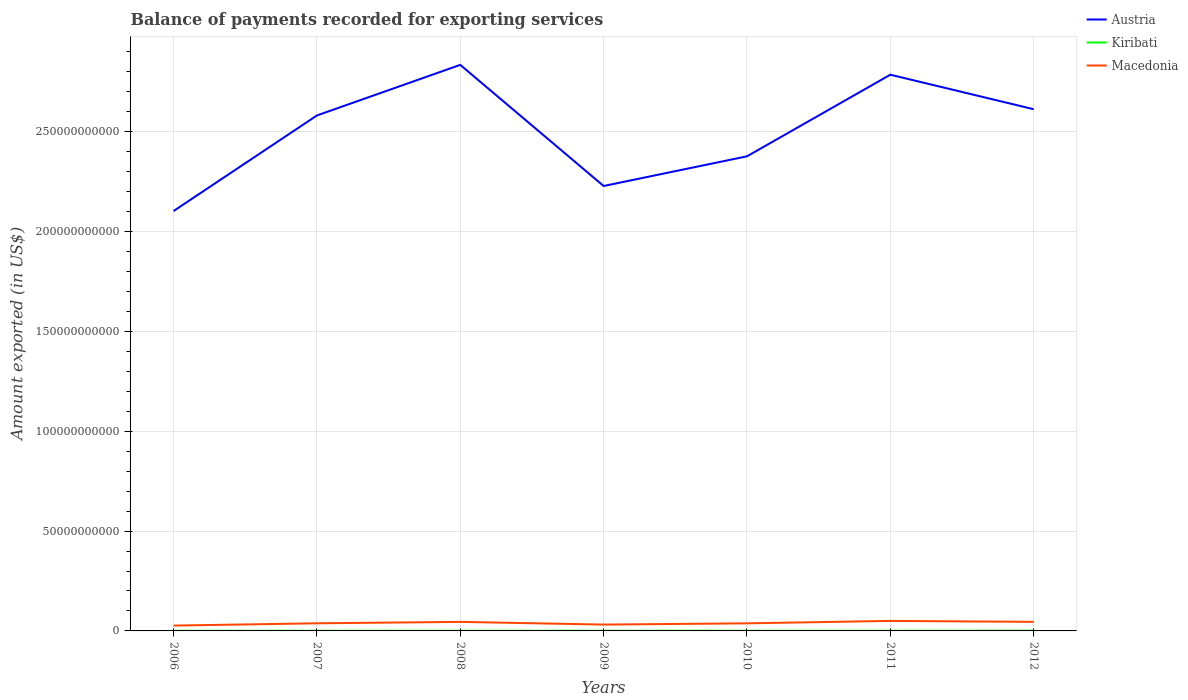How many different coloured lines are there?
Give a very brief answer. 3. Across all years, what is the maximum amount exported in Austria?
Offer a very short reply. 2.10e+11. What is the total amount exported in Austria in the graph?
Provide a short and direct response. 2.22e+1. What is the difference between the highest and the second highest amount exported in Macedonia?
Ensure brevity in your answer.  2.34e+09. How many lines are there?
Your answer should be very brief. 3. What is the difference between two consecutive major ticks on the Y-axis?
Ensure brevity in your answer.  5.00e+1. Are the values on the major ticks of Y-axis written in scientific E-notation?
Offer a very short reply. No. Does the graph contain grids?
Ensure brevity in your answer.  Yes. Where does the legend appear in the graph?
Offer a terse response. Top right. How many legend labels are there?
Keep it short and to the point. 3. How are the legend labels stacked?
Give a very brief answer. Vertical. What is the title of the graph?
Offer a terse response. Balance of payments recorded for exporting services. Does "Uganda" appear as one of the legend labels in the graph?
Your response must be concise. No. What is the label or title of the X-axis?
Provide a short and direct response. Years. What is the label or title of the Y-axis?
Make the answer very short. Amount exported (in US$). What is the Amount exported (in US$) in Austria in 2006?
Give a very brief answer. 2.10e+11. What is the Amount exported (in US$) of Kiribati in 2006?
Your answer should be very brief. 6.04e+07. What is the Amount exported (in US$) in Macedonia in 2006?
Your answer should be very brief. 2.68e+09. What is the Amount exported (in US$) of Austria in 2007?
Your answer should be very brief. 2.58e+11. What is the Amount exported (in US$) in Kiribati in 2007?
Your answer should be very brief. 8.29e+07. What is the Amount exported (in US$) in Macedonia in 2007?
Offer a very short reply. 3.82e+09. What is the Amount exported (in US$) in Austria in 2008?
Your response must be concise. 2.83e+11. What is the Amount exported (in US$) in Kiribati in 2008?
Offer a terse response. 9.38e+07. What is the Amount exported (in US$) of Macedonia in 2008?
Your answer should be very brief. 4.52e+09. What is the Amount exported (in US$) in Austria in 2009?
Your answer should be very brief. 2.23e+11. What is the Amount exported (in US$) of Kiribati in 2009?
Provide a succinct answer. 7.75e+07. What is the Amount exported (in US$) of Macedonia in 2009?
Offer a terse response. 3.18e+09. What is the Amount exported (in US$) of Austria in 2010?
Your answer should be compact. 2.38e+11. What is the Amount exported (in US$) of Kiribati in 2010?
Make the answer very short. 9.54e+07. What is the Amount exported (in US$) in Macedonia in 2010?
Ensure brevity in your answer.  3.80e+09. What is the Amount exported (in US$) of Austria in 2011?
Make the answer very short. 2.79e+11. What is the Amount exported (in US$) of Kiribati in 2011?
Offer a terse response. 9.75e+07. What is the Amount exported (in US$) in Macedonia in 2011?
Ensure brevity in your answer.  5.02e+09. What is the Amount exported (in US$) of Austria in 2012?
Give a very brief answer. 2.61e+11. What is the Amount exported (in US$) of Kiribati in 2012?
Offer a very short reply. 1.24e+08. What is the Amount exported (in US$) of Macedonia in 2012?
Your answer should be compact. 4.53e+09. Across all years, what is the maximum Amount exported (in US$) of Austria?
Ensure brevity in your answer.  2.83e+11. Across all years, what is the maximum Amount exported (in US$) of Kiribati?
Provide a succinct answer. 1.24e+08. Across all years, what is the maximum Amount exported (in US$) of Macedonia?
Provide a short and direct response. 5.02e+09. Across all years, what is the minimum Amount exported (in US$) of Austria?
Ensure brevity in your answer.  2.10e+11. Across all years, what is the minimum Amount exported (in US$) of Kiribati?
Give a very brief answer. 6.04e+07. Across all years, what is the minimum Amount exported (in US$) in Macedonia?
Offer a terse response. 2.68e+09. What is the total Amount exported (in US$) in Austria in the graph?
Keep it short and to the point. 1.75e+12. What is the total Amount exported (in US$) in Kiribati in the graph?
Offer a terse response. 6.32e+08. What is the total Amount exported (in US$) in Macedonia in the graph?
Your response must be concise. 2.76e+1. What is the difference between the Amount exported (in US$) in Austria in 2006 and that in 2007?
Your response must be concise. -4.79e+1. What is the difference between the Amount exported (in US$) of Kiribati in 2006 and that in 2007?
Your answer should be compact. -2.25e+07. What is the difference between the Amount exported (in US$) of Macedonia in 2006 and that in 2007?
Provide a succinct answer. -1.14e+09. What is the difference between the Amount exported (in US$) in Austria in 2006 and that in 2008?
Keep it short and to the point. -7.32e+1. What is the difference between the Amount exported (in US$) in Kiribati in 2006 and that in 2008?
Offer a terse response. -3.34e+07. What is the difference between the Amount exported (in US$) of Macedonia in 2006 and that in 2008?
Give a very brief answer. -1.85e+09. What is the difference between the Amount exported (in US$) of Austria in 2006 and that in 2009?
Ensure brevity in your answer.  -1.25e+1. What is the difference between the Amount exported (in US$) in Kiribati in 2006 and that in 2009?
Offer a very short reply. -1.72e+07. What is the difference between the Amount exported (in US$) of Macedonia in 2006 and that in 2009?
Make the answer very short. -4.97e+08. What is the difference between the Amount exported (in US$) of Austria in 2006 and that in 2010?
Your response must be concise. -2.74e+1. What is the difference between the Amount exported (in US$) of Kiribati in 2006 and that in 2010?
Provide a succinct answer. -3.50e+07. What is the difference between the Amount exported (in US$) in Macedonia in 2006 and that in 2010?
Make the answer very short. -1.12e+09. What is the difference between the Amount exported (in US$) in Austria in 2006 and that in 2011?
Your answer should be compact. -6.83e+1. What is the difference between the Amount exported (in US$) of Kiribati in 2006 and that in 2011?
Your response must be concise. -3.71e+07. What is the difference between the Amount exported (in US$) in Macedonia in 2006 and that in 2011?
Ensure brevity in your answer.  -2.34e+09. What is the difference between the Amount exported (in US$) of Austria in 2006 and that in 2012?
Provide a succinct answer. -5.10e+1. What is the difference between the Amount exported (in US$) of Kiribati in 2006 and that in 2012?
Provide a succinct answer. -6.40e+07. What is the difference between the Amount exported (in US$) in Macedonia in 2006 and that in 2012?
Ensure brevity in your answer.  -1.86e+09. What is the difference between the Amount exported (in US$) of Austria in 2007 and that in 2008?
Ensure brevity in your answer.  -2.53e+1. What is the difference between the Amount exported (in US$) in Kiribati in 2007 and that in 2008?
Offer a very short reply. -1.09e+07. What is the difference between the Amount exported (in US$) in Macedonia in 2007 and that in 2008?
Your answer should be very brief. -7.03e+08. What is the difference between the Amount exported (in US$) in Austria in 2007 and that in 2009?
Your answer should be very brief. 3.53e+1. What is the difference between the Amount exported (in US$) of Kiribati in 2007 and that in 2009?
Your answer should be very brief. 5.38e+06. What is the difference between the Amount exported (in US$) in Macedonia in 2007 and that in 2009?
Keep it short and to the point. 6.46e+08. What is the difference between the Amount exported (in US$) of Austria in 2007 and that in 2010?
Keep it short and to the point. 2.05e+1. What is the difference between the Amount exported (in US$) in Kiribati in 2007 and that in 2010?
Your response must be concise. -1.25e+07. What is the difference between the Amount exported (in US$) of Macedonia in 2007 and that in 2010?
Your answer should be compact. 2.02e+07. What is the difference between the Amount exported (in US$) in Austria in 2007 and that in 2011?
Offer a very short reply. -2.04e+1. What is the difference between the Amount exported (in US$) in Kiribati in 2007 and that in 2011?
Ensure brevity in your answer.  -1.46e+07. What is the difference between the Amount exported (in US$) in Macedonia in 2007 and that in 2011?
Your response must be concise. -1.20e+09. What is the difference between the Amount exported (in US$) of Austria in 2007 and that in 2012?
Keep it short and to the point. -3.13e+09. What is the difference between the Amount exported (in US$) of Kiribati in 2007 and that in 2012?
Your answer should be very brief. -4.15e+07. What is the difference between the Amount exported (in US$) in Macedonia in 2007 and that in 2012?
Your response must be concise. -7.14e+08. What is the difference between the Amount exported (in US$) in Austria in 2008 and that in 2009?
Your answer should be very brief. 6.07e+1. What is the difference between the Amount exported (in US$) in Kiribati in 2008 and that in 2009?
Your answer should be very brief. 1.63e+07. What is the difference between the Amount exported (in US$) in Macedonia in 2008 and that in 2009?
Offer a terse response. 1.35e+09. What is the difference between the Amount exported (in US$) in Austria in 2008 and that in 2010?
Give a very brief answer. 4.58e+1. What is the difference between the Amount exported (in US$) in Kiribati in 2008 and that in 2010?
Keep it short and to the point. -1.56e+06. What is the difference between the Amount exported (in US$) in Macedonia in 2008 and that in 2010?
Your answer should be compact. 7.23e+08. What is the difference between the Amount exported (in US$) in Austria in 2008 and that in 2011?
Give a very brief answer. 4.93e+09. What is the difference between the Amount exported (in US$) of Kiribati in 2008 and that in 2011?
Your answer should be very brief. -3.68e+06. What is the difference between the Amount exported (in US$) of Macedonia in 2008 and that in 2011?
Give a very brief answer. -4.95e+08. What is the difference between the Amount exported (in US$) of Austria in 2008 and that in 2012?
Your response must be concise. 2.22e+1. What is the difference between the Amount exported (in US$) in Kiribati in 2008 and that in 2012?
Make the answer very short. -3.05e+07. What is the difference between the Amount exported (in US$) in Macedonia in 2008 and that in 2012?
Offer a terse response. -1.05e+07. What is the difference between the Amount exported (in US$) of Austria in 2009 and that in 2010?
Provide a short and direct response. -1.49e+1. What is the difference between the Amount exported (in US$) in Kiribati in 2009 and that in 2010?
Your answer should be compact. -1.79e+07. What is the difference between the Amount exported (in US$) in Macedonia in 2009 and that in 2010?
Provide a succinct answer. -6.26e+08. What is the difference between the Amount exported (in US$) of Austria in 2009 and that in 2011?
Offer a terse response. -5.57e+1. What is the difference between the Amount exported (in US$) of Kiribati in 2009 and that in 2011?
Your response must be concise. -2.00e+07. What is the difference between the Amount exported (in US$) of Macedonia in 2009 and that in 2011?
Make the answer very short. -1.84e+09. What is the difference between the Amount exported (in US$) in Austria in 2009 and that in 2012?
Ensure brevity in your answer.  -3.85e+1. What is the difference between the Amount exported (in US$) of Kiribati in 2009 and that in 2012?
Give a very brief answer. -4.68e+07. What is the difference between the Amount exported (in US$) in Macedonia in 2009 and that in 2012?
Give a very brief answer. -1.36e+09. What is the difference between the Amount exported (in US$) of Austria in 2010 and that in 2011?
Keep it short and to the point. -4.09e+1. What is the difference between the Amount exported (in US$) of Kiribati in 2010 and that in 2011?
Provide a succinct answer. -2.12e+06. What is the difference between the Amount exported (in US$) in Macedonia in 2010 and that in 2011?
Offer a terse response. -1.22e+09. What is the difference between the Amount exported (in US$) in Austria in 2010 and that in 2012?
Ensure brevity in your answer.  -2.36e+1. What is the difference between the Amount exported (in US$) in Kiribati in 2010 and that in 2012?
Ensure brevity in your answer.  -2.90e+07. What is the difference between the Amount exported (in US$) of Macedonia in 2010 and that in 2012?
Offer a terse response. -7.34e+08. What is the difference between the Amount exported (in US$) in Austria in 2011 and that in 2012?
Your answer should be compact. 1.73e+1. What is the difference between the Amount exported (in US$) of Kiribati in 2011 and that in 2012?
Your answer should be compact. -2.69e+07. What is the difference between the Amount exported (in US$) in Macedonia in 2011 and that in 2012?
Offer a very short reply. 4.85e+08. What is the difference between the Amount exported (in US$) of Austria in 2006 and the Amount exported (in US$) of Kiribati in 2007?
Offer a very short reply. 2.10e+11. What is the difference between the Amount exported (in US$) of Austria in 2006 and the Amount exported (in US$) of Macedonia in 2007?
Offer a very short reply. 2.06e+11. What is the difference between the Amount exported (in US$) of Kiribati in 2006 and the Amount exported (in US$) of Macedonia in 2007?
Provide a short and direct response. -3.76e+09. What is the difference between the Amount exported (in US$) of Austria in 2006 and the Amount exported (in US$) of Kiribati in 2008?
Your answer should be compact. 2.10e+11. What is the difference between the Amount exported (in US$) of Austria in 2006 and the Amount exported (in US$) of Macedonia in 2008?
Your answer should be very brief. 2.06e+11. What is the difference between the Amount exported (in US$) of Kiribati in 2006 and the Amount exported (in US$) of Macedonia in 2008?
Make the answer very short. -4.46e+09. What is the difference between the Amount exported (in US$) in Austria in 2006 and the Amount exported (in US$) in Kiribati in 2009?
Make the answer very short. 2.10e+11. What is the difference between the Amount exported (in US$) of Austria in 2006 and the Amount exported (in US$) of Macedonia in 2009?
Make the answer very short. 2.07e+11. What is the difference between the Amount exported (in US$) of Kiribati in 2006 and the Amount exported (in US$) of Macedonia in 2009?
Your response must be concise. -3.11e+09. What is the difference between the Amount exported (in US$) of Austria in 2006 and the Amount exported (in US$) of Kiribati in 2010?
Provide a short and direct response. 2.10e+11. What is the difference between the Amount exported (in US$) of Austria in 2006 and the Amount exported (in US$) of Macedonia in 2010?
Your answer should be very brief. 2.06e+11. What is the difference between the Amount exported (in US$) of Kiribati in 2006 and the Amount exported (in US$) of Macedonia in 2010?
Offer a very short reply. -3.74e+09. What is the difference between the Amount exported (in US$) of Austria in 2006 and the Amount exported (in US$) of Kiribati in 2011?
Your answer should be very brief. 2.10e+11. What is the difference between the Amount exported (in US$) of Austria in 2006 and the Amount exported (in US$) of Macedonia in 2011?
Ensure brevity in your answer.  2.05e+11. What is the difference between the Amount exported (in US$) of Kiribati in 2006 and the Amount exported (in US$) of Macedonia in 2011?
Your answer should be very brief. -4.96e+09. What is the difference between the Amount exported (in US$) in Austria in 2006 and the Amount exported (in US$) in Kiribati in 2012?
Give a very brief answer. 2.10e+11. What is the difference between the Amount exported (in US$) in Austria in 2006 and the Amount exported (in US$) in Macedonia in 2012?
Provide a succinct answer. 2.06e+11. What is the difference between the Amount exported (in US$) in Kiribati in 2006 and the Amount exported (in US$) in Macedonia in 2012?
Your answer should be compact. -4.47e+09. What is the difference between the Amount exported (in US$) of Austria in 2007 and the Amount exported (in US$) of Kiribati in 2008?
Your answer should be compact. 2.58e+11. What is the difference between the Amount exported (in US$) of Austria in 2007 and the Amount exported (in US$) of Macedonia in 2008?
Keep it short and to the point. 2.54e+11. What is the difference between the Amount exported (in US$) in Kiribati in 2007 and the Amount exported (in US$) in Macedonia in 2008?
Provide a short and direct response. -4.44e+09. What is the difference between the Amount exported (in US$) of Austria in 2007 and the Amount exported (in US$) of Kiribati in 2009?
Your answer should be compact. 2.58e+11. What is the difference between the Amount exported (in US$) in Austria in 2007 and the Amount exported (in US$) in Macedonia in 2009?
Provide a short and direct response. 2.55e+11. What is the difference between the Amount exported (in US$) of Kiribati in 2007 and the Amount exported (in US$) of Macedonia in 2009?
Your answer should be compact. -3.09e+09. What is the difference between the Amount exported (in US$) of Austria in 2007 and the Amount exported (in US$) of Kiribati in 2010?
Make the answer very short. 2.58e+11. What is the difference between the Amount exported (in US$) of Austria in 2007 and the Amount exported (in US$) of Macedonia in 2010?
Offer a terse response. 2.54e+11. What is the difference between the Amount exported (in US$) of Kiribati in 2007 and the Amount exported (in US$) of Macedonia in 2010?
Keep it short and to the point. -3.72e+09. What is the difference between the Amount exported (in US$) of Austria in 2007 and the Amount exported (in US$) of Kiribati in 2011?
Offer a terse response. 2.58e+11. What is the difference between the Amount exported (in US$) in Austria in 2007 and the Amount exported (in US$) in Macedonia in 2011?
Ensure brevity in your answer.  2.53e+11. What is the difference between the Amount exported (in US$) in Kiribati in 2007 and the Amount exported (in US$) in Macedonia in 2011?
Give a very brief answer. -4.94e+09. What is the difference between the Amount exported (in US$) in Austria in 2007 and the Amount exported (in US$) in Kiribati in 2012?
Your response must be concise. 2.58e+11. What is the difference between the Amount exported (in US$) in Austria in 2007 and the Amount exported (in US$) in Macedonia in 2012?
Give a very brief answer. 2.54e+11. What is the difference between the Amount exported (in US$) in Kiribati in 2007 and the Amount exported (in US$) in Macedonia in 2012?
Your answer should be very brief. -4.45e+09. What is the difference between the Amount exported (in US$) in Austria in 2008 and the Amount exported (in US$) in Kiribati in 2009?
Make the answer very short. 2.83e+11. What is the difference between the Amount exported (in US$) of Austria in 2008 and the Amount exported (in US$) of Macedonia in 2009?
Provide a succinct answer. 2.80e+11. What is the difference between the Amount exported (in US$) of Kiribati in 2008 and the Amount exported (in US$) of Macedonia in 2009?
Ensure brevity in your answer.  -3.08e+09. What is the difference between the Amount exported (in US$) of Austria in 2008 and the Amount exported (in US$) of Kiribati in 2010?
Make the answer very short. 2.83e+11. What is the difference between the Amount exported (in US$) in Austria in 2008 and the Amount exported (in US$) in Macedonia in 2010?
Provide a short and direct response. 2.80e+11. What is the difference between the Amount exported (in US$) in Kiribati in 2008 and the Amount exported (in US$) in Macedonia in 2010?
Provide a succinct answer. -3.71e+09. What is the difference between the Amount exported (in US$) in Austria in 2008 and the Amount exported (in US$) in Kiribati in 2011?
Offer a terse response. 2.83e+11. What is the difference between the Amount exported (in US$) in Austria in 2008 and the Amount exported (in US$) in Macedonia in 2011?
Give a very brief answer. 2.78e+11. What is the difference between the Amount exported (in US$) in Kiribati in 2008 and the Amount exported (in US$) in Macedonia in 2011?
Offer a very short reply. -4.93e+09. What is the difference between the Amount exported (in US$) in Austria in 2008 and the Amount exported (in US$) in Kiribati in 2012?
Offer a very short reply. 2.83e+11. What is the difference between the Amount exported (in US$) in Austria in 2008 and the Amount exported (in US$) in Macedonia in 2012?
Offer a terse response. 2.79e+11. What is the difference between the Amount exported (in US$) in Kiribati in 2008 and the Amount exported (in US$) in Macedonia in 2012?
Your answer should be very brief. -4.44e+09. What is the difference between the Amount exported (in US$) in Austria in 2009 and the Amount exported (in US$) in Kiribati in 2010?
Your answer should be compact. 2.23e+11. What is the difference between the Amount exported (in US$) in Austria in 2009 and the Amount exported (in US$) in Macedonia in 2010?
Your answer should be very brief. 2.19e+11. What is the difference between the Amount exported (in US$) in Kiribati in 2009 and the Amount exported (in US$) in Macedonia in 2010?
Make the answer very short. -3.72e+09. What is the difference between the Amount exported (in US$) of Austria in 2009 and the Amount exported (in US$) of Kiribati in 2011?
Give a very brief answer. 2.23e+11. What is the difference between the Amount exported (in US$) in Austria in 2009 and the Amount exported (in US$) in Macedonia in 2011?
Your response must be concise. 2.18e+11. What is the difference between the Amount exported (in US$) in Kiribati in 2009 and the Amount exported (in US$) in Macedonia in 2011?
Offer a terse response. -4.94e+09. What is the difference between the Amount exported (in US$) of Austria in 2009 and the Amount exported (in US$) of Kiribati in 2012?
Ensure brevity in your answer.  2.23e+11. What is the difference between the Amount exported (in US$) of Austria in 2009 and the Amount exported (in US$) of Macedonia in 2012?
Your answer should be compact. 2.18e+11. What is the difference between the Amount exported (in US$) in Kiribati in 2009 and the Amount exported (in US$) in Macedonia in 2012?
Offer a very short reply. -4.46e+09. What is the difference between the Amount exported (in US$) of Austria in 2010 and the Amount exported (in US$) of Kiribati in 2011?
Offer a terse response. 2.38e+11. What is the difference between the Amount exported (in US$) in Austria in 2010 and the Amount exported (in US$) in Macedonia in 2011?
Provide a succinct answer. 2.33e+11. What is the difference between the Amount exported (in US$) of Kiribati in 2010 and the Amount exported (in US$) of Macedonia in 2011?
Your answer should be very brief. -4.92e+09. What is the difference between the Amount exported (in US$) in Austria in 2010 and the Amount exported (in US$) in Kiribati in 2012?
Provide a succinct answer. 2.38e+11. What is the difference between the Amount exported (in US$) of Austria in 2010 and the Amount exported (in US$) of Macedonia in 2012?
Keep it short and to the point. 2.33e+11. What is the difference between the Amount exported (in US$) of Kiribati in 2010 and the Amount exported (in US$) of Macedonia in 2012?
Offer a very short reply. -4.44e+09. What is the difference between the Amount exported (in US$) in Austria in 2011 and the Amount exported (in US$) in Kiribati in 2012?
Offer a very short reply. 2.78e+11. What is the difference between the Amount exported (in US$) in Austria in 2011 and the Amount exported (in US$) in Macedonia in 2012?
Your response must be concise. 2.74e+11. What is the difference between the Amount exported (in US$) in Kiribati in 2011 and the Amount exported (in US$) in Macedonia in 2012?
Keep it short and to the point. -4.44e+09. What is the average Amount exported (in US$) of Austria per year?
Give a very brief answer. 2.50e+11. What is the average Amount exported (in US$) of Kiribati per year?
Make the answer very short. 9.03e+07. What is the average Amount exported (in US$) in Macedonia per year?
Keep it short and to the point. 3.94e+09. In the year 2006, what is the difference between the Amount exported (in US$) of Austria and Amount exported (in US$) of Kiribati?
Your response must be concise. 2.10e+11. In the year 2006, what is the difference between the Amount exported (in US$) in Austria and Amount exported (in US$) in Macedonia?
Give a very brief answer. 2.08e+11. In the year 2006, what is the difference between the Amount exported (in US$) of Kiribati and Amount exported (in US$) of Macedonia?
Offer a very short reply. -2.62e+09. In the year 2007, what is the difference between the Amount exported (in US$) of Austria and Amount exported (in US$) of Kiribati?
Your answer should be very brief. 2.58e+11. In the year 2007, what is the difference between the Amount exported (in US$) of Austria and Amount exported (in US$) of Macedonia?
Your answer should be very brief. 2.54e+11. In the year 2007, what is the difference between the Amount exported (in US$) of Kiribati and Amount exported (in US$) of Macedonia?
Keep it short and to the point. -3.74e+09. In the year 2008, what is the difference between the Amount exported (in US$) in Austria and Amount exported (in US$) in Kiribati?
Your answer should be very brief. 2.83e+11. In the year 2008, what is the difference between the Amount exported (in US$) in Austria and Amount exported (in US$) in Macedonia?
Your response must be concise. 2.79e+11. In the year 2008, what is the difference between the Amount exported (in US$) in Kiribati and Amount exported (in US$) in Macedonia?
Provide a short and direct response. -4.43e+09. In the year 2009, what is the difference between the Amount exported (in US$) in Austria and Amount exported (in US$) in Kiribati?
Provide a short and direct response. 2.23e+11. In the year 2009, what is the difference between the Amount exported (in US$) of Austria and Amount exported (in US$) of Macedonia?
Make the answer very short. 2.20e+11. In the year 2009, what is the difference between the Amount exported (in US$) of Kiribati and Amount exported (in US$) of Macedonia?
Your answer should be compact. -3.10e+09. In the year 2010, what is the difference between the Amount exported (in US$) of Austria and Amount exported (in US$) of Kiribati?
Your answer should be very brief. 2.38e+11. In the year 2010, what is the difference between the Amount exported (in US$) in Austria and Amount exported (in US$) in Macedonia?
Offer a very short reply. 2.34e+11. In the year 2010, what is the difference between the Amount exported (in US$) of Kiribati and Amount exported (in US$) of Macedonia?
Offer a terse response. -3.71e+09. In the year 2011, what is the difference between the Amount exported (in US$) in Austria and Amount exported (in US$) in Kiribati?
Ensure brevity in your answer.  2.78e+11. In the year 2011, what is the difference between the Amount exported (in US$) in Austria and Amount exported (in US$) in Macedonia?
Offer a terse response. 2.74e+11. In the year 2011, what is the difference between the Amount exported (in US$) in Kiribati and Amount exported (in US$) in Macedonia?
Provide a succinct answer. -4.92e+09. In the year 2012, what is the difference between the Amount exported (in US$) in Austria and Amount exported (in US$) in Kiribati?
Provide a short and direct response. 2.61e+11. In the year 2012, what is the difference between the Amount exported (in US$) in Austria and Amount exported (in US$) in Macedonia?
Your answer should be very brief. 2.57e+11. In the year 2012, what is the difference between the Amount exported (in US$) in Kiribati and Amount exported (in US$) in Macedonia?
Your answer should be very brief. -4.41e+09. What is the ratio of the Amount exported (in US$) of Austria in 2006 to that in 2007?
Offer a terse response. 0.81. What is the ratio of the Amount exported (in US$) of Kiribati in 2006 to that in 2007?
Keep it short and to the point. 0.73. What is the ratio of the Amount exported (in US$) of Macedonia in 2006 to that in 2007?
Keep it short and to the point. 0.7. What is the ratio of the Amount exported (in US$) of Austria in 2006 to that in 2008?
Ensure brevity in your answer.  0.74. What is the ratio of the Amount exported (in US$) of Kiribati in 2006 to that in 2008?
Keep it short and to the point. 0.64. What is the ratio of the Amount exported (in US$) of Macedonia in 2006 to that in 2008?
Give a very brief answer. 0.59. What is the ratio of the Amount exported (in US$) of Austria in 2006 to that in 2009?
Make the answer very short. 0.94. What is the ratio of the Amount exported (in US$) in Kiribati in 2006 to that in 2009?
Keep it short and to the point. 0.78. What is the ratio of the Amount exported (in US$) in Macedonia in 2006 to that in 2009?
Make the answer very short. 0.84. What is the ratio of the Amount exported (in US$) in Austria in 2006 to that in 2010?
Give a very brief answer. 0.88. What is the ratio of the Amount exported (in US$) in Kiribati in 2006 to that in 2010?
Your answer should be very brief. 0.63. What is the ratio of the Amount exported (in US$) of Macedonia in 2006 to that in 2010?
Keep it short and to the point. 0.7. What is the ratio of the Amount exported (in US$) of Austria in 2006 to that in 2011?
Keep it short and to the point. 0.75. What is the ratio of the Amount exported (in US$) in Kiribati in 2006 to that in 2011?
Ensure brevity in your answer.  0.62. What is the ratio of the Amount exported (in US$) of Macedonia in 2006 to that in 2011?
Give a very brief answer. 0.53. What is the ratio of the Amount exported (in US$) in Austria in 2006 to that in 2012?
Your answer should be compact. 0.8. What is the ratio of the Amount exported (in US$) of Kiribati in 2006 to that in 2012?
Make the answer very short. 0.49. What is the ratio of the Amount exported (in US$) in Macedonia in 2006 to that in 2012?
Ensure brevity in your answer.  0.59. What is the ratio of the Amount exported (in US$) of Austria in 2007 to that in 2008?
Provide a succinct answer. 0.91. What is the ratio of the Amount exported (in US$) in Kiribati in 2007 to that in 2008?
Provide a short and direct response. 0.88. What is the ratio of the Amount exported (in US$) in Macedonia in 2007 to that in 2008?
Ensure brevity in your answer.  0.84. What is the ratio of the Amount exported (in US$) in Austria in 2007 to that in 2009?
Offer a terse response. 1.16. What is the ratio of the Amount exported (in US$) in Kiribati in 2007 to that in 2009?
Make the answer very short. 1.07. What is the ratio of the Amount exported (in US$) in Macedonia in 2007 to that in 2009?
Provide a short and direct response. 1.2. What is the ratio of the Amount exported (in US$) in Austria in 2007 to that in 2010?
Provide a succinct answer. 1.09. What is the ratio of the Amount exported (in US$) in Kiribati in 2007 to that in 2010?
Offer a terse response. 0.87. What is the ratio of the Amount exported (in US$) of Macedonia in 2007 to that in 2010?
Keep it short and to the point. 1.01. What is the ratio of the Amount exported (in US$) of Austria in 2007 to that in 2011?
Provide a short and direct response. 0.93. What is the ratio of the Amount exported (in US$) in Kiribati in 2007 to that in 2011?
Your response must be concise. 0.85. What is the ratio of the Amount exported (in US$) of Macedonia in 2007 to that in 2011?
Make the answer very short. 0.76. What is the ratio of the Amount exported (in US$) of Austria in 2007 to that in 2012?
Your answer should be very brief. 0.99. What is the ratio of the Amount exported (in US$) of Kiribati in 2007 to that in 2012?
Offer a very short reply. 0.67. What is the ratio of the Amount exported (in US$) of Macedonia in 2007 to that in 2012?
Give a very brief answer. 0.84. What is the ratio of the Amount exported (in US$) in Austria in 2008 to that in 2009?
Provide a short and direct response. 1.27. What is the ratio of the Amount exported (in US$) of Kiribati in 2008 to that in 2009?
Your answer should be compact. 1.21. What is the ratio of the Amount exported (in US$) in Macedonia in 2008 to that in 2009?
Your answer should be compact. 1.42. What is the ratio of the Amount exported (in US$) in Austria in 2008 to that in 2010?
Your answer should be very brief. 1.19. What is the ratio of the Amount exported (in US$) in Kiribati in 2008 to that in 2010?
Offer a very short reply. 0.98. What is the ratio of the Amount exported (in US$) in Macedonia in 2008 to that in 2010?
Offer a very short reply. 1.19. What is the ratio of the Amount exported (in US$) of Austria in 2008 to that in 2011?
Give a very brief answer. 1.02. What is the ratio of the Amount exported (in US$) in Kiribati in 2008 to that in 2011?
Make the answer very short. 0.96. What is the ratio of the Amount exported (in US$) of Macedonia in 2008 to that in 2011?
Keep it short and to the point. 0.9. What is the ratio of the Amount exported (in US$) in Austria in 2008 to that in 2012?
Keep it short and to the point. 1.08. What is the ratio of the Amount exported (in US$) of Kiribati in 2008 to that in 2012?
Provide a short and direct response. 0.75. What is the ratio of the Amount exported (in US$) in Kiribati in 2009 to that in 2010?
Provide a succinct answer. 0.81. What is the ratio of the Amount exported (in US$) in Macedonia in 2009 to that in 2010?
Provide a short and direct response. 0.84. What is the ratio of the Amount exported (in US$) of Austria in 2009 to that in 2011?
Your answer should be compact. 0.8. What is the ratio of the Amount exported (in US$) in Kiribati in 2009 to that in 2011?
Make the answer very short. 0.8. What is the ratio of the Amount exported (in US$) in Macedonia in 2009 to that in 2011?
Your response must be concise. 0.63. What is the ratio of the Amount exported (in US$) of Austria in 2009 to that in 2012?
Make the answer very short. 0.85. What is the ratio of the Amount exported (in US$) of Kiribati in 2009 to that in 2012?
Offer a terse response. 0.62. What is the ratio of the Amount exported (in US$) of Macedonia in 2009 to that in 2012?
Your response must be concise. 0.7. What is the ratio of the Amount exported (in US$) of Austria in 2010 to that in 2011?
Your response must be concise. 0.85. What is the ratio of the Amount exported (in US$) in Kiribati in 2010 to that in 2011?
Provide a short and direct response. 0.98. What is the ratio of the Amount exported (in US$) in Macedonia in 2010 to that in 2011?
Your answer should be very brief. 0.76. What is the ratio of the Amount exported (in US$) of Austria in 2010 to that in 2012?
Your answer should be compact. 0.91. What is the ratio of the Amount exported (in US$) of Kiribati in 2010 to that in 2012?
Ensure brevity in your answer.  0.77. What is the ratio of the Amount exported (in US$) in Macedonia in 2010 to that in 2012?
Provide a short and direct response. 0.84. What is the ratio of the Amount exported (in US$) of Austria in 2011 to that in 2012?
Your answer should be compact. 1.07. What is the ratio of the Amount exported (in US$) in Kiribati in 2011 to that in 2012?
Offer a very short reply. 0.78. What is the ratio of the Amount exported (in US$) of Macedonia in 2011 to that in 2012?
Give a very brief answer. 1.11. What is the difference between the highest and the second highest Amount exported (in US$) in Austria?
Your answer should be very brief. 4.93e+09. What is the difference between the highest and the second highest Amount exported (in US$) in Kiribati?
Offer a very short reply. 2.69e+07. What is the difference between the highest and the second highest Amount exported (in US$) of Macedonia?
Your answer should be very brief. 4.85e+08. What is the difference between the highest and the lowest Amount exported (in US$) of Austria?
Offer a terse response. 7.32e+1. What is the difference between the highest and the lowest Amount exported (in US$) in Kiribati?
Ensure brevity in your answer.  6.40e+07. What is the difference between the highest and the lowest Amount exported (in US$) in Macedonia?
Keep it short and to the point. 2.34e+09. 